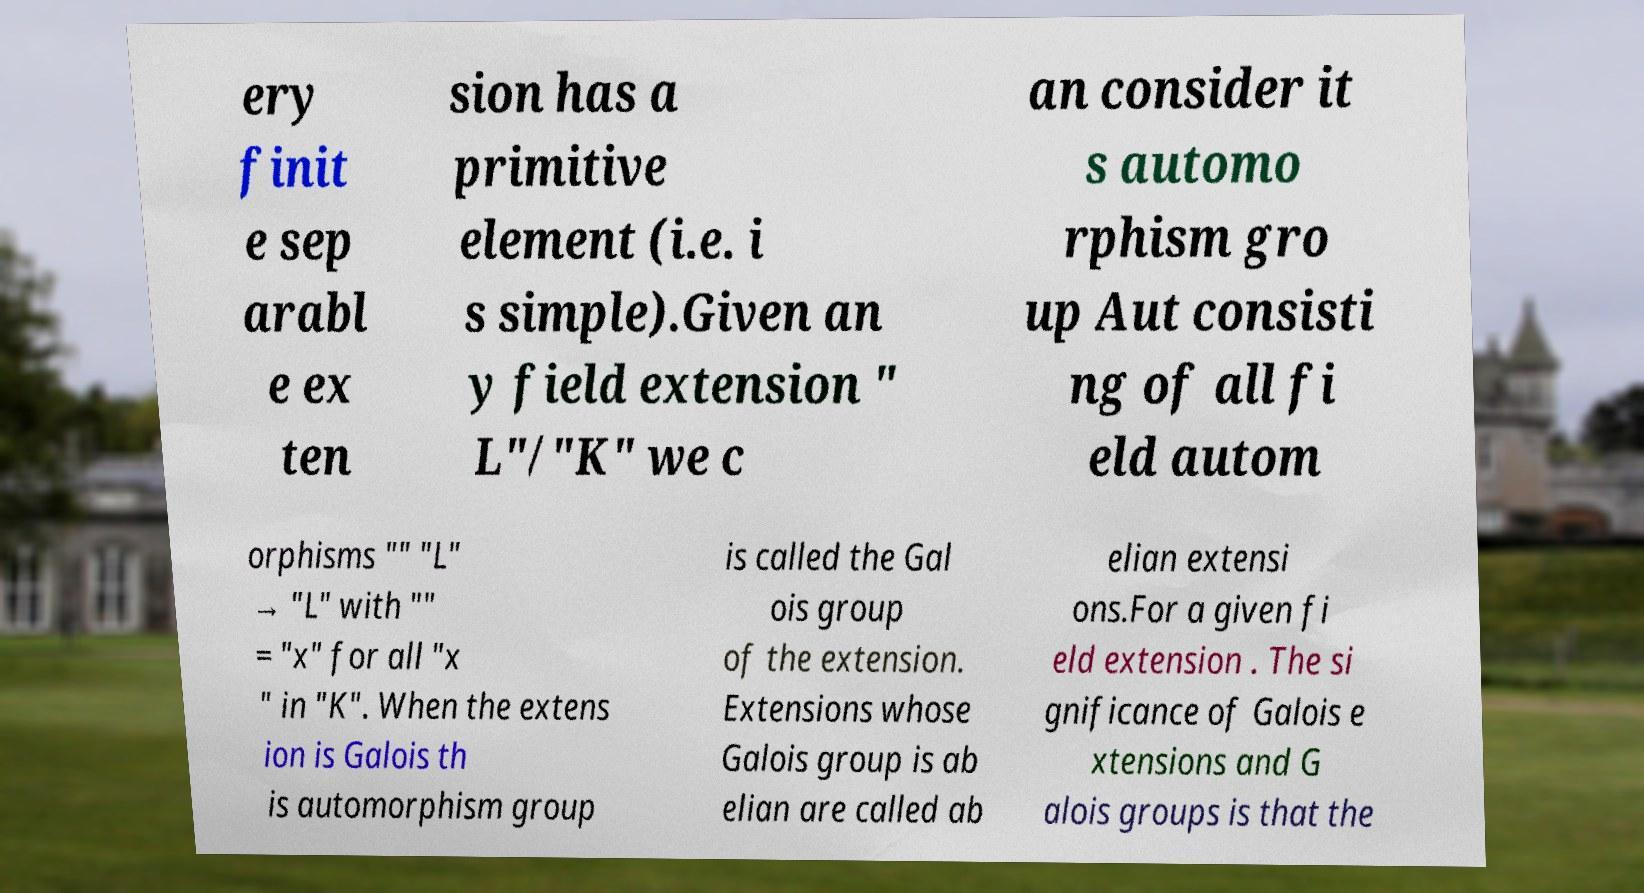I need the written content from this picture converted into text. Can you do that? ery finit e sep arabl e ex ten sion has a primitive element (i.e. i s simple).Given an y field extension " L"/"K" we c an consider it s automo rphism gro up Aut consisti ng of all fi eld autom orphisms "" "L" → "L" with "" = "x" for all "x " in "K". When the extens ion is Galois th is automorphism group is called the Gal ois group of the extension. Extensions whose Galois group is ab elian are called ab elian extensi ons.For a given fi eld extension . The si gnificance of Galois e xtensions and G alois groups is that the 